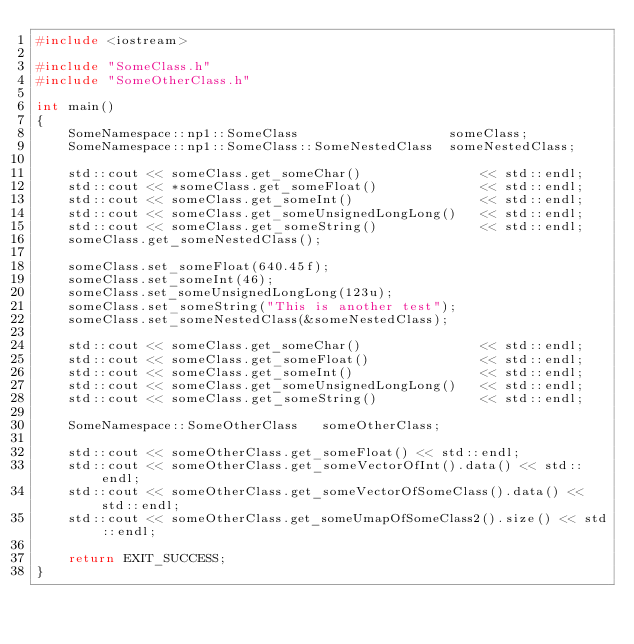<code> <loc_0><loc_0><loc_500><loc_500><_C++_>#include <iostream>

#include "SomeClass.h"
#include "SomeOtherClass.h"

int main()
{
	SomeNamespace::np1::SomeClass					someClass;
	SomeNamespace::np1::SomeClass::SomeNestedClass	someNestedClass;

	std::cout << someClass.get_someChar()				<< std::endl;
	std::cout << *someClass.get_someFloat()				<< std::endl;
	std::cout << someClass.get_someInt()				<< std::endl;
	std::cout << someClass.get_someUnsignedLongLong()	<< std::endl;
	std::cout << someClass.get_someString()				<< std::endl;
	someClass.get_someNestedClass();

	someClass.set_someFloat(640.45f);
	someClass.set_someInt(46);
	someClass.set_someUnsignedLongLong(123u);
	someClass.set_someString("This is another test");
	someClass.set_someNestedClass(&someNestedClass);

	std::cout << someClass.get_someChar()				<< std::endl;
	std::cout << someClass.get_someFloat()				<< std::endl;
	std::cout << someClass.get_someInt()				<< std::endl;
	std::cout << someClass.get_someUnsignedLongLong()	<< std::endl;
	std::cout << someClass.get_someString()				<< std::endl;

	SomeNamespace::SomeOtherClass	someOtherClass;

	std::cout << someOtherClass.get_someFloat() << std::endl;
	std::cout << someOtherClass.get_someVectorOfInt().data() << std::endl;
	std::cout << someOtherClass.get_someVectorOfSomeClass().data() << std::endl;
	std::cout << someOtherClass.get_someUmapOfSomeClass2().size() << std::endl;

	return EXIT_SUCCESS;
}</code> 